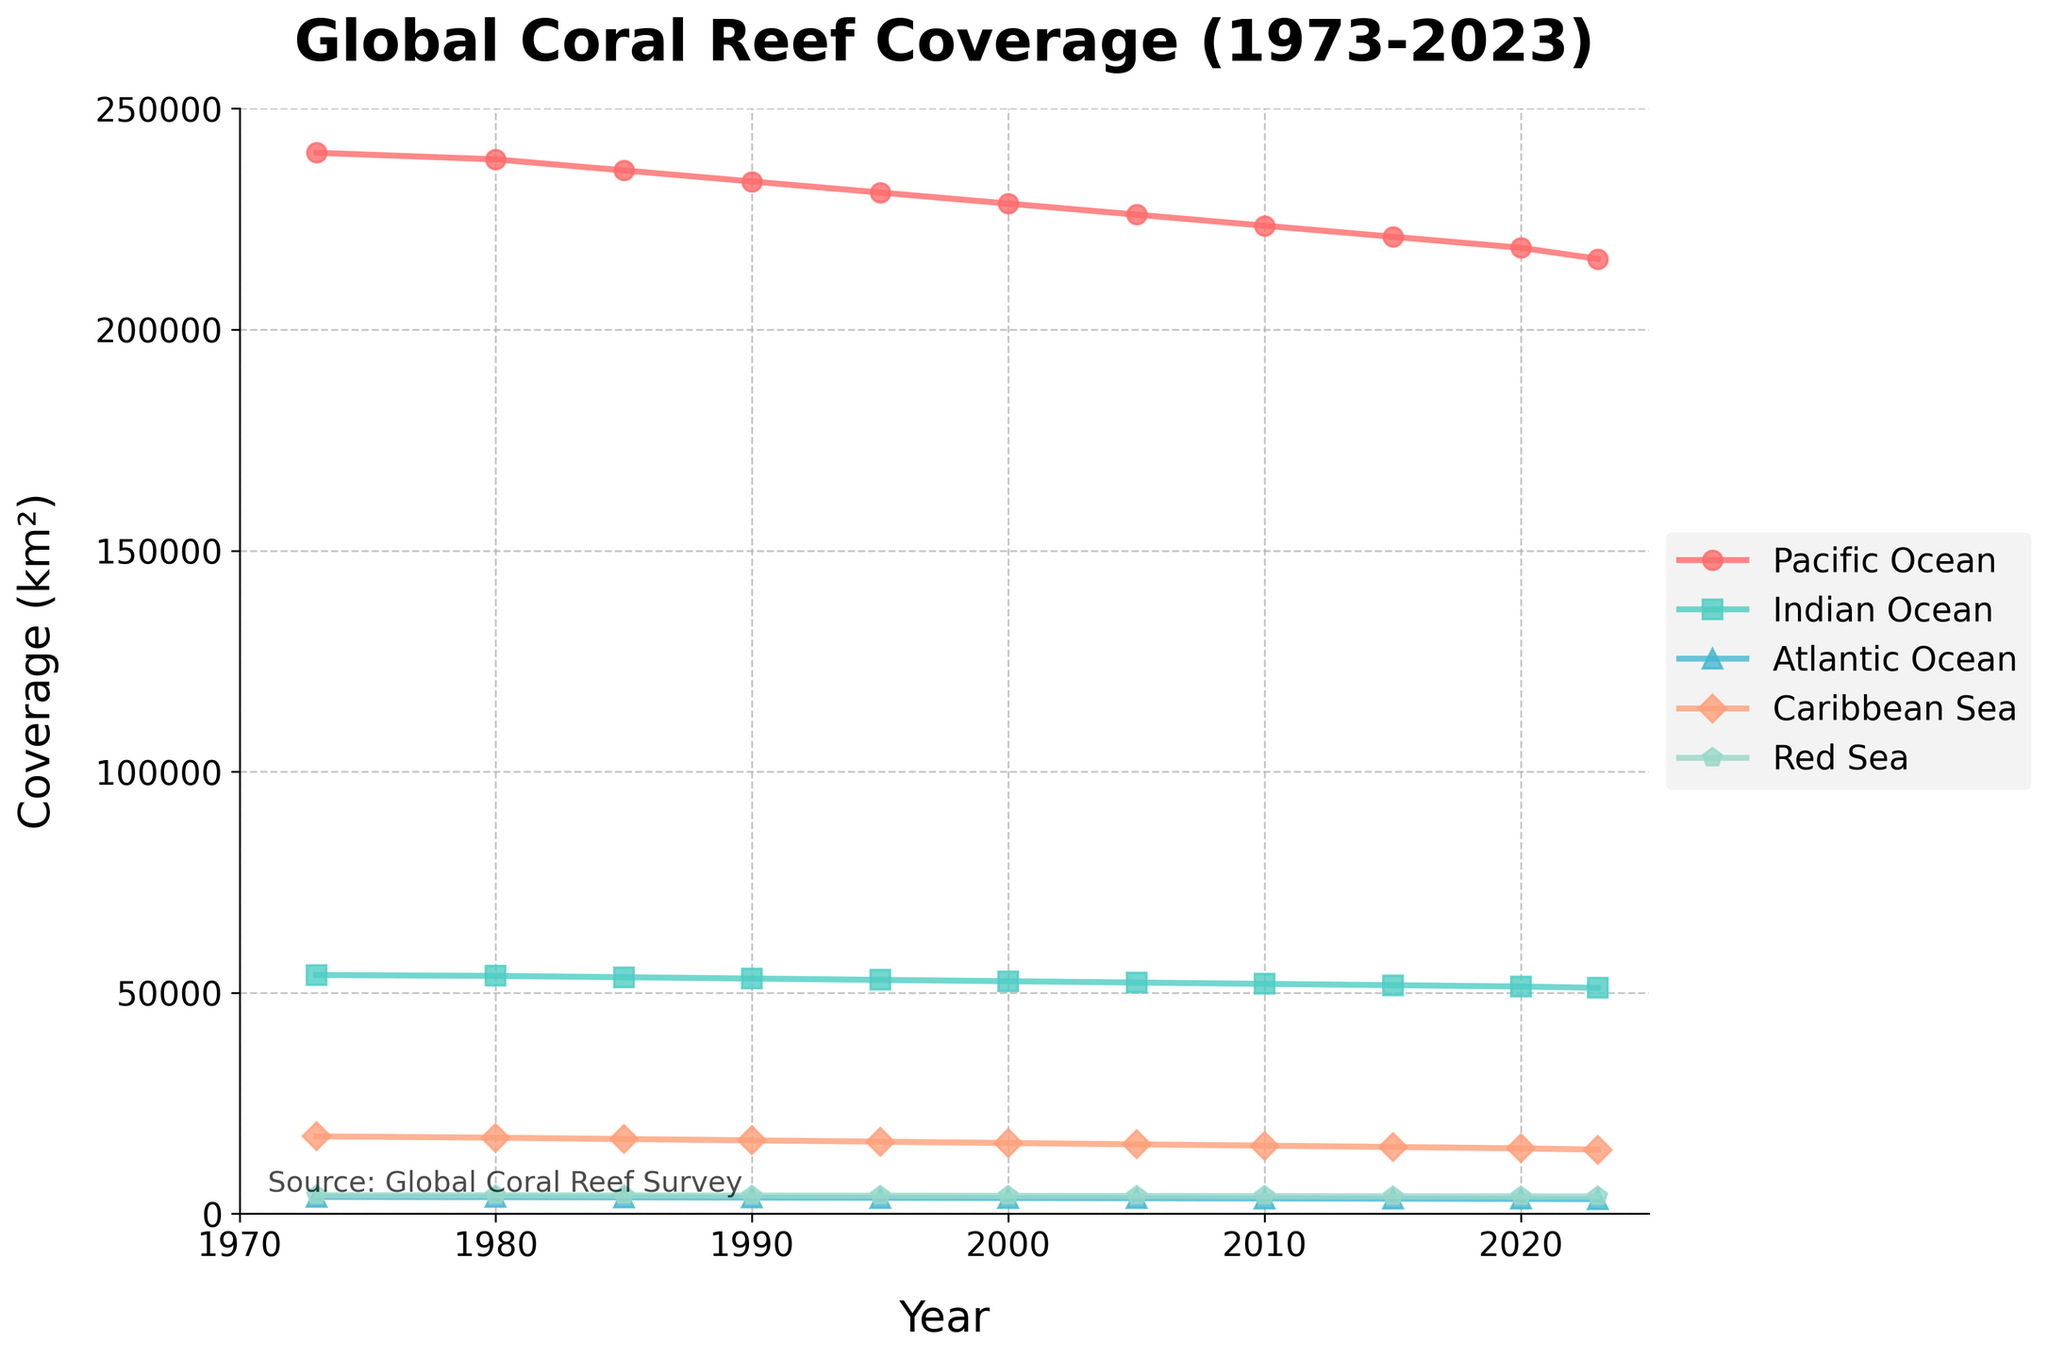Which ocean had the largest coral reef coverage in 1973? Refer to the figure's starting point (1973) and compare the coverage of each ocean. The Pacific Ocean has the highest coverage value among all listed, at 240,000 km².
Answer: Pacific Ocean How did the coral reef coverage in the Indian Ocean change from 1973 to 2023? Look at the plot for the Indian Ocean and measure how the coverage reduced from 1973 to 2023. Coverage decreased from 54,000 km² to 51,100 km², a difference of 2,900 km².
Answer: Decreased by 2,900 km² Which ocean showed the most significant decline in coral reef coverage over the 50 years? Identify the ocean with the largest decline by examining the initial and final coverage values for each. The Pacific Ocean showed the most considerable decline, from 240,000 km² to 216,000 km², a drop of 24,000 km².
Answer: Pacific Ocean Which region consistently has the smallest coral reef coverage throughout the entire period? Find the line that consistently stays at the lowest point in the figure over the given years. The Atlantic Ocean has the lowest coverage values throughout the period.
Answer: Atlantic Ocean Calculate the average coral reef coverage for the Caribbean Sea between 1973 and 2023. Add up all the values for the Caribbean Sea and divide by the number of years recorded (11 values). \( (17500 + 17200 + 16900 + 16600 + 16300 + 16000 + 15700 + 15400 + 15100 + 14800 + 14500) / 11 = 15950 \)
Answer: 15950 km² Compare the coral reef coverage in the Red Sea in 1990 and 2020. Which year had higher coverage? Look at the respective values in 1990 and 2020. The values show 4120 km² in 1990 and 3940 km² in 2020, so 1990 had higher coverage.
Answer: 1990 What is the total coral reef coverage for all regions combined in the year 2010? Sum the coral reef coverage values of all oceans in 2010. \( 223500 + 52000 + 3450 + 15400 + 4000 = 298350 \) km².
Answer: 298350 km² Which region has the steepest decline in coral reef coverage between 1973 and 2023? Calculate the decline by subtracting the final value (2023) from the initial value (1973) for each region. The Pacific Ocean has the steepest decline of 24,000 km².
Answer: Pacific Ocean Is the coral reef coverage in the Caribbean Sea greater or less than 16,000 km² in 2000? Refer to the corresponding value for the Caribbean Sea in 2000, which is 16,000 km².
Answer: Equal Has the coral reef coverage in the Atlantic Ocean ever exceeded 4,000 km² between 1973 and 2023? Cross-check all the values for the Atlantic Ocean in each year; they are consistently below 4,000 km².
Answer: No 